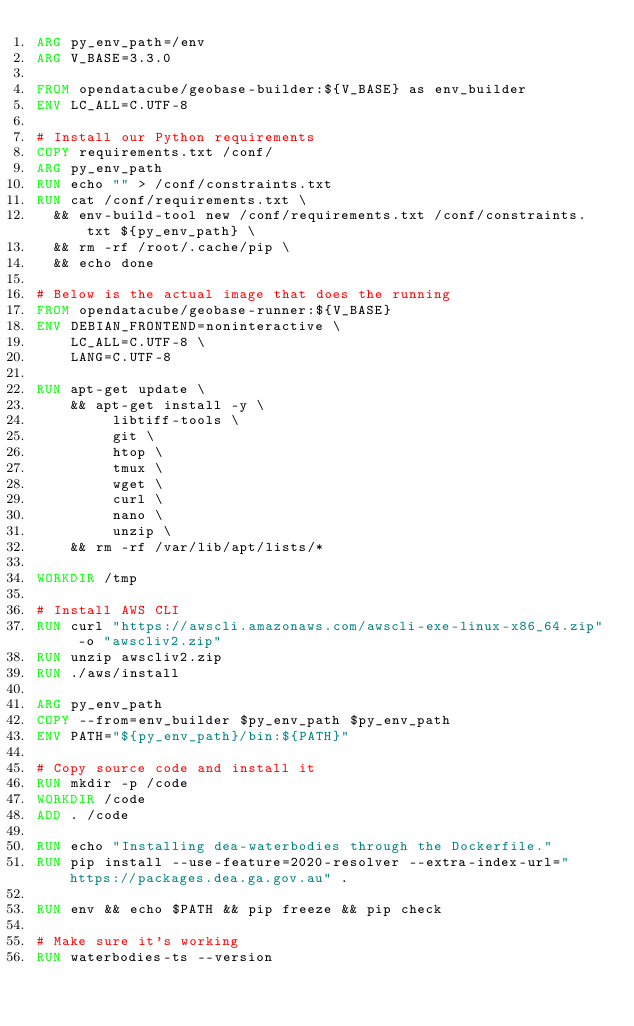<code> <loc_0><loc_0><loc_500><loc_500><_Dockerfile_>ARG py_env_path=/env
ARG V_BASE=3.3.0

FROM opendatacube/geobase-builder:${V_BASE} as env_builder
ENV LC_ALL=C.UTF-8

# Install our Python requirements
COPY requirements.txt /conf/
ARG py_env_path
RUN echo "" > /conf/constraints.txt
RUN cat /conf/requirements.txt \
  && env-build-tool new /conf/requirements.txt /conf/constraints.txt ${py_env_path} \
  && rm -rf /root/.cache/pip \
  && echo done

# Below is the actual image that does the running
FROM opendatacube/geobase-runner:${V_BASE}
ENV DEBIAN_FRONTEND=noninteractive \
    LC_ALL=C.UTF-8 \
    LANG=C.UTF-8
    
RUN apt-get update \
    && apt-get install -y \
         libtiff-tools \
         git \
         htop \
         tmux \
         wget \
         curl \
         nano \
         unzip \
    && rm -rf /var/lib/apt/lists/*

WORKDIR /tmp

# Install AWS CLI
RUN curl "https://awscli.amazonaws.com/awscli-exe-linux-x86_64.zip" -o "awscliv2.zip"
RUN unzip awscliv2.zip
RUN ./aws/install

ARG py_env_path
COPY --from=env_builder $py_env_path $py_env_path
ENV PATH="${py_env_path}/bin:${PATH}"

# Copy source code and install it
RUN mkdir -p /code
WORKDIR /code
ADD . /code

RUN echo "Installing dea-waterbodies through the Dockerfile."
RUN pip install --use-feature=2020-resolver --extra-index-url="https://packages.dea.ga.gov.au" .

RUN env && echo $PATH && pip freeze && pip check

# Make sure it's working
RUN waterbodies-ts --version
</code> 